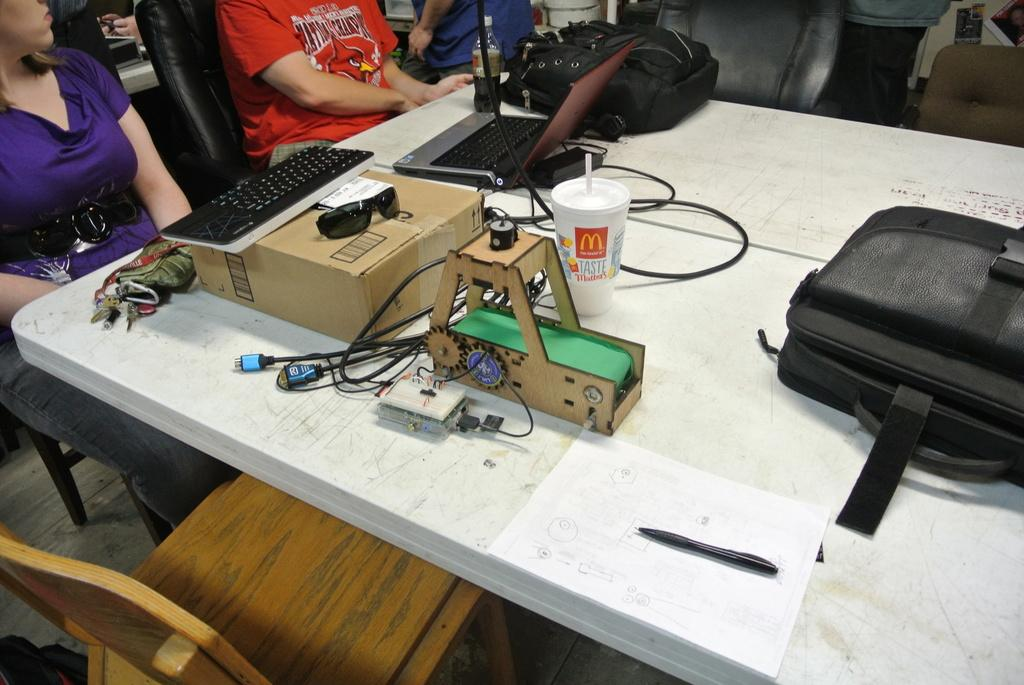What piece of furniture is in the image? There is a table in the image. What electronic device is on the table? A keyboard and a laptop are on the table. What type of bags are on the table? There are bags on the table. What other objects can be seen on the table? There are other objects on the table. What are the people in the image doing? There are people sitting on chairs in the image. What type of loaf is being served on the table in the image? There is no loaf present in the image; the table contains a keyboard, a laptop, bags, and other unspecified objects. 